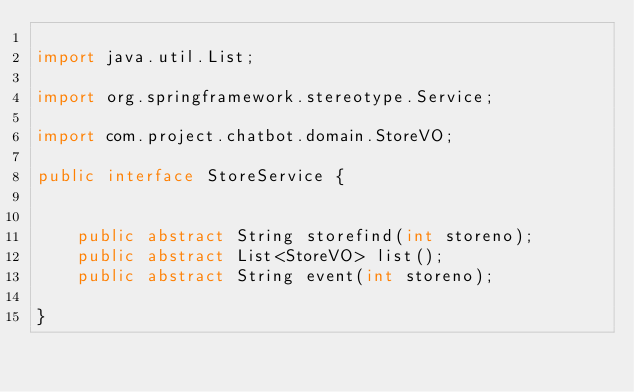<code> <loc_0><loc_0><loc_500><loc_500><_Java_>
import java.util.List;

import org.springframework.stereotype.Service;

import com.project.chatbot.domain.StoreVO;

public interface StoreService {
	
	
	public abstract String storefind(int storeno);
	public abstract List<StoreVO> list();
	public abstract String event(int storeno);

}
</code> 